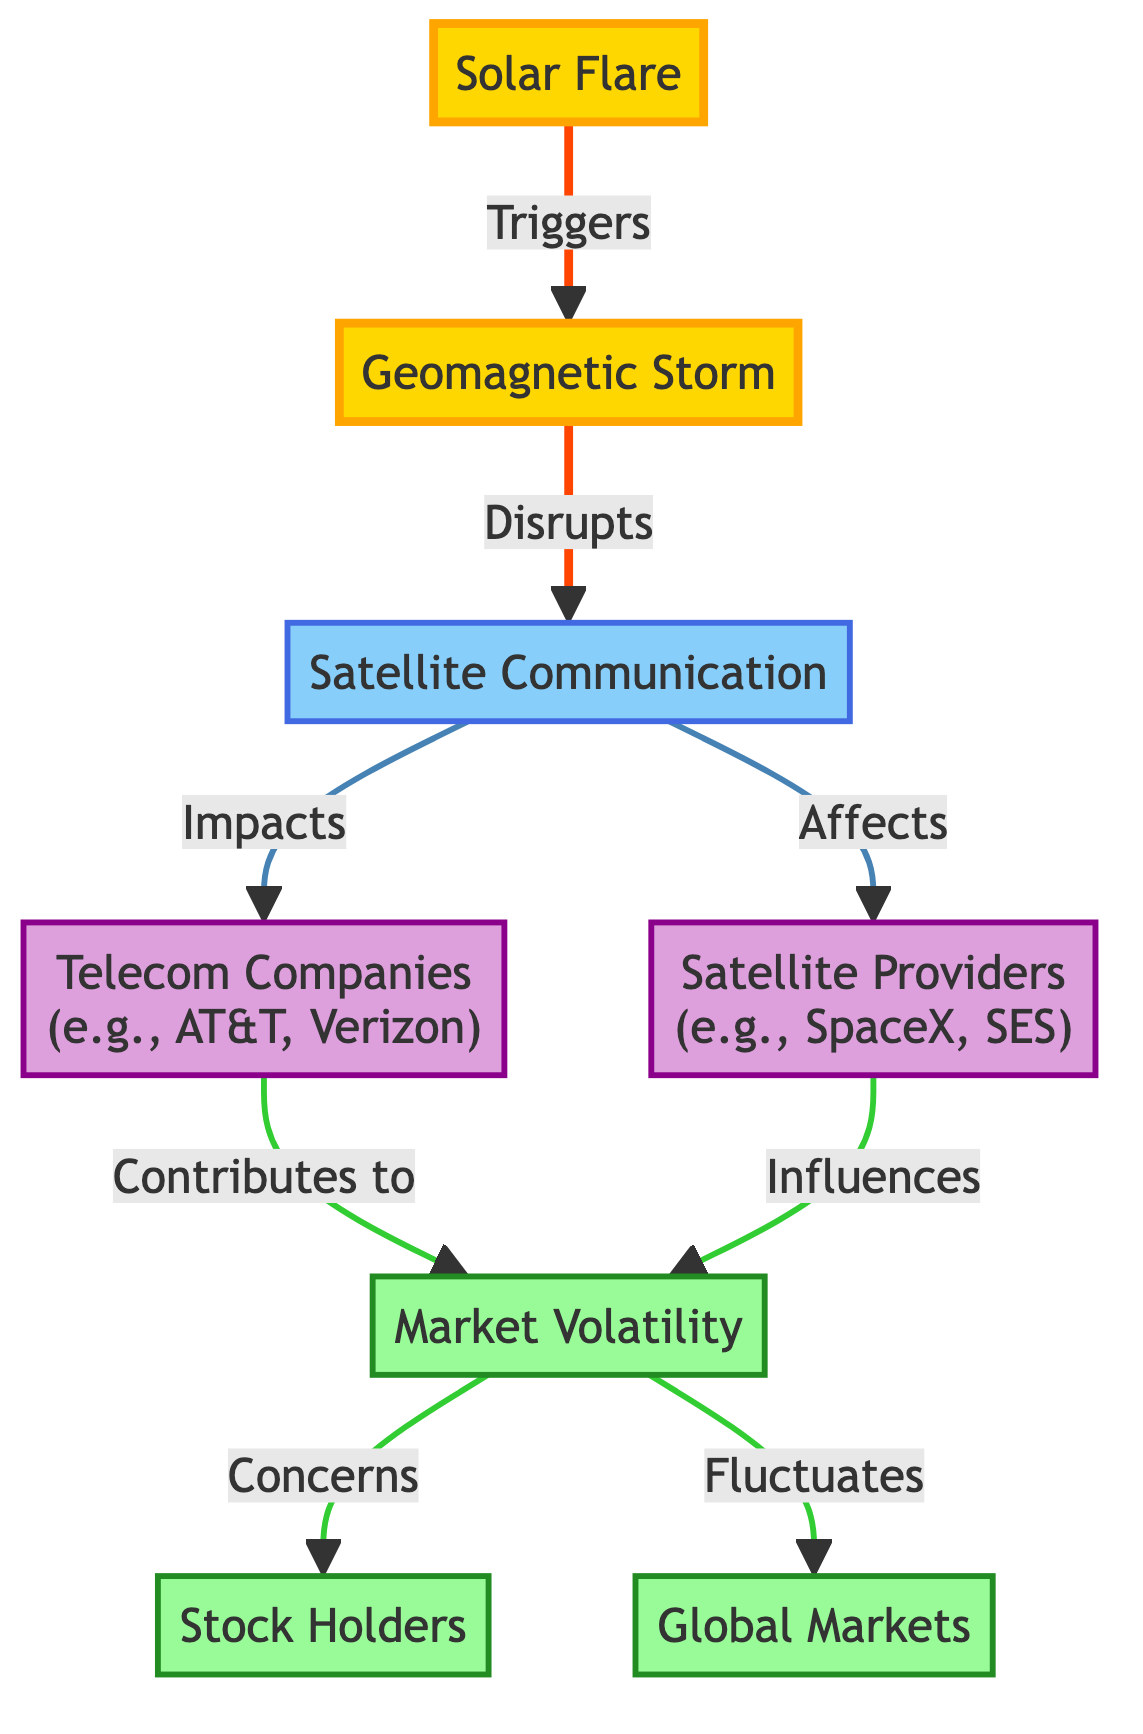What event initiates the sequence of impacts shown in the diagram? The sequence begins with the "Solar Flare," which triggers a geomagnetic storm. The first arrow in the diagram points from the solar flare to the geomagnetic storm, indicating it as the starting point.
Answer: Solar Flare How many companies are affected by satellite communication disruptions? There are two specific company types affected by the disruptions in satellite communication indicated on the diagram: "Telecom Companies" and "Satellite Providers."
Answer: 2 Which event directly leads to market volatility in the diagram? The diagram shows that "Market Volatility" is influenced by the contributions of both "Telecom Companies" and "Satellite Providers," following their impact from satellite communication disruptions.
Answer: Telecom Companies, Satellite Providers What term describes the status of stockholders as a result of market volatility? Stockholders are described as being "Concerned" due to market volatility, as depicted in the flow leading from market volatility to stockholders.
Answer: Concerned What is the relationship between geomagnetic storms and satellite communication? Geomagnetic storms "Disrupt" satellite communication, as indicated by the arrow that connects these two elements in the diagram, showcasing a direct impact relationship.
Answer: Disrupts How does market volatility affect global markets according to the diagram? Market volatility "Fluctuates" global markets, illustrating that changes in market volatility have a direct effect on the broader global market landscape, following the link in the diagram.
Answer: Fluctuates Which diagram type specifically focuses on astronomical phenomena and their impacts? The diagram type is an "Astronomy Diagram," a format that links astronomical events to their effects on various earthly elements, illustrating connections in a visual flow.
Answer: Astronomy Diagram What is the overall impact of solar flares on global markets as shown in the diagram? The diagram indicates that solar flares lead to geomagnetic storms, which disrupt satellite communication, contribute to market volatility, and ultimately result in fluctuating global markets, showing a chain of effects that start with solar activity.
Answer: Fluctuate 